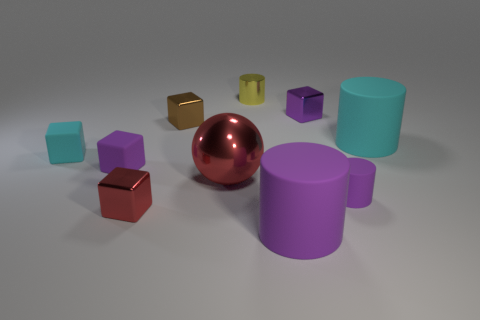There is a small block that is the same color as the large ball; what is its material?
Ensure brevity in your answer.  Metal. What number of other things are there of the same color as the big metallic ball?
Your answer should be very brief. 1. How many other objects are the same shape as the large cyan thing?
Provide a succinct answer. 3. Is there a cyan cube?
Give a very brief answer. Yes. Is there anything else that has the same material as the tiny purple cylinder?
Your answer should be very brief. Yes. Is there a brown ball that has the same material as the tiny cyan thing?
Give a very brief answer. No. There is another purple cylinder that is the same size as the metallic cylinder; what material is it?
Your answer should be compact. Rubber. What number of other metal objects have the same shape as the large red object?
Your answer should be compact. 0. The cyan cube that is the same material as the large cyan cylinder is what size?
Give a very brief answer. Small. What is the small purple thing that is both on the left side of the tiny purple matte cylinder and to the right of the tiny red thing made of?
Your response must be concise. Metal. 